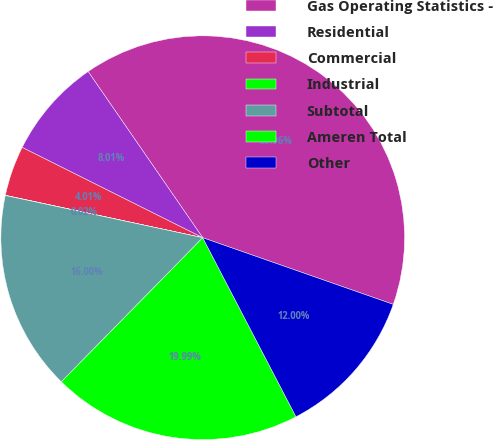Convert chart to OTSL. <chart><loc_0><loc_0><loc_500><loc_500><pie_chart><fcel>Gas Operating Statistics -<fcel>Residential<fcel>Commercial<fcel>Industrial<fcel>Subtotal<fcel>Ameren Total<fcel>Other<nl><fcel>39.96%<fcel>8.01%<fcel>4.01%<fcel>0.02%<fcel>16.0%<fcel>19.99%<fcel>12.0%<nl></chart> 